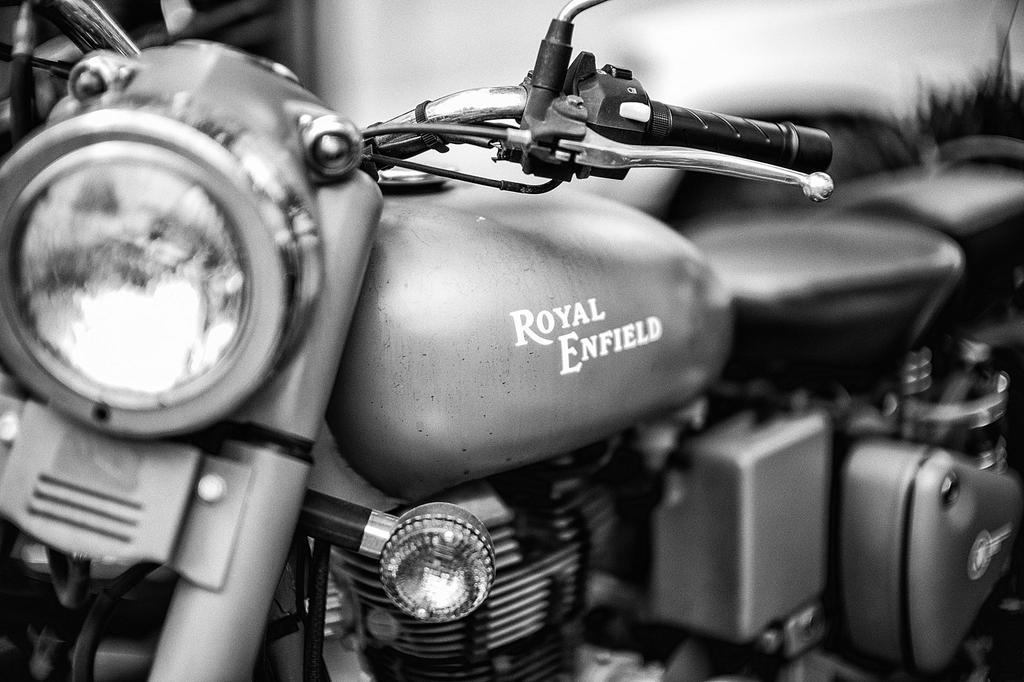What is the main subject in the foreground of the image? There is a bike in the foreground of the image. What can be observed about the background of the image? The background of the image is blurred. What type of screw can be seen on the bike in the image? There is no screw visible on the bike in the image. Can you tell me how many tramps are sitting on the bike in the image? There are no tramps present in the image; it features a bike in the foreground. 